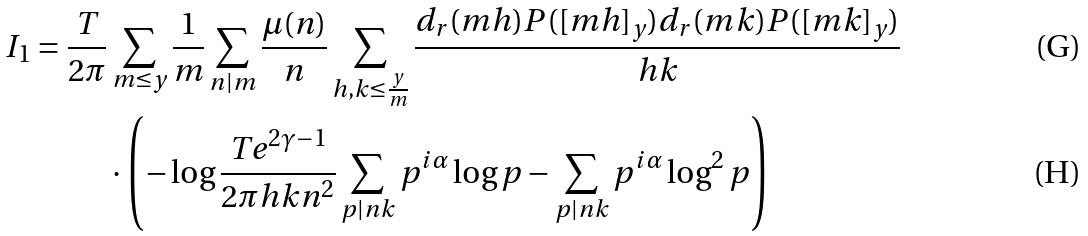Convert formula to latex. <formula><loc_0><loc_0><loc_500><loc_500>I _ { 1 } = \frac { T } { 2 \pi } & \sum _ { m \leq y } \frac { 1 } { m } \sum _ { n | m } \frac { \mu ( n ) } { n } \sum _ { h , k \leq \frac { y } { m } } \frac { d _ { r } ( m h ) P ( [ m h ] _ { y } ) d _ { r } ( m k ) P ( [ m k ] _ { y } ) } { h k } \\ & \cdot \left ( - \log \frac { T e ^ { 2 \gamma - 1 } } { 2 \pi h k n ^ { 2 } } \sum _ { p | n k } p ^ { i \alpha } \log p - \sum _ { p | n k } p ^ { i \alpha } \log ^ { 2 } p \right )</formula> 